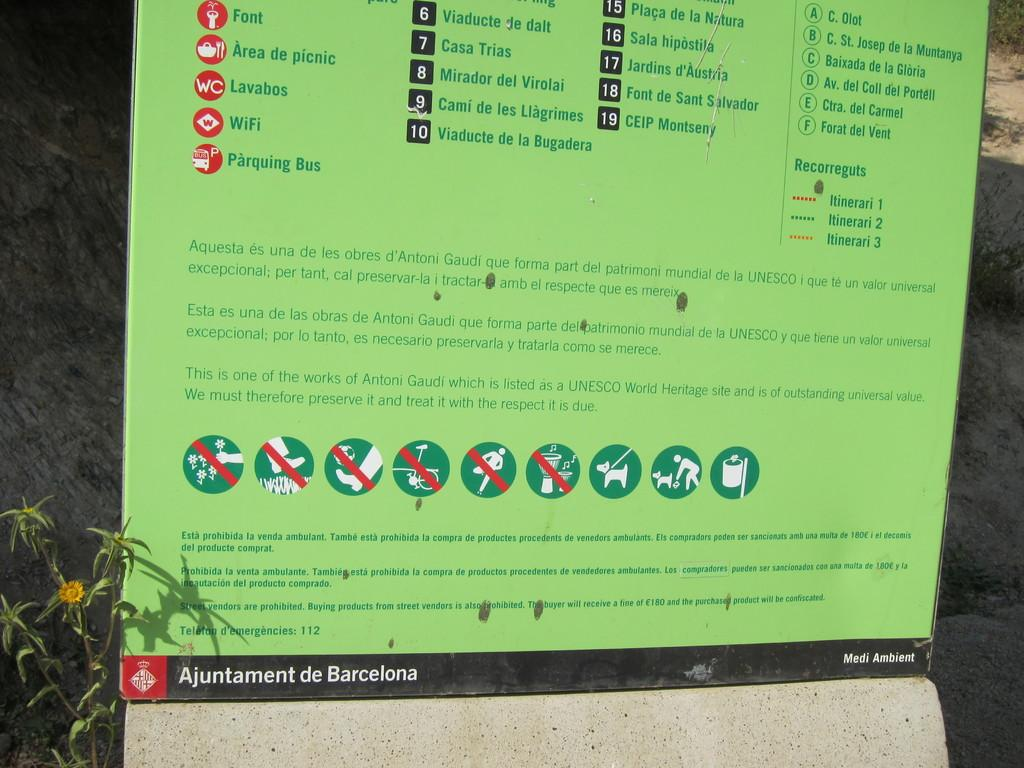What is the main subject of the image? The main subject of the image is a paper with instructions. What can be observed about the instructions on the paper? The instructions are in green color. What else is visible in the image besides the paper with instructions? There is a plant on the left side of the image. What type of crayon is being used to draw on the plant in the image? There is no crayon or drawing on the plant in the image; it is a plant without any additional markings or objects. 